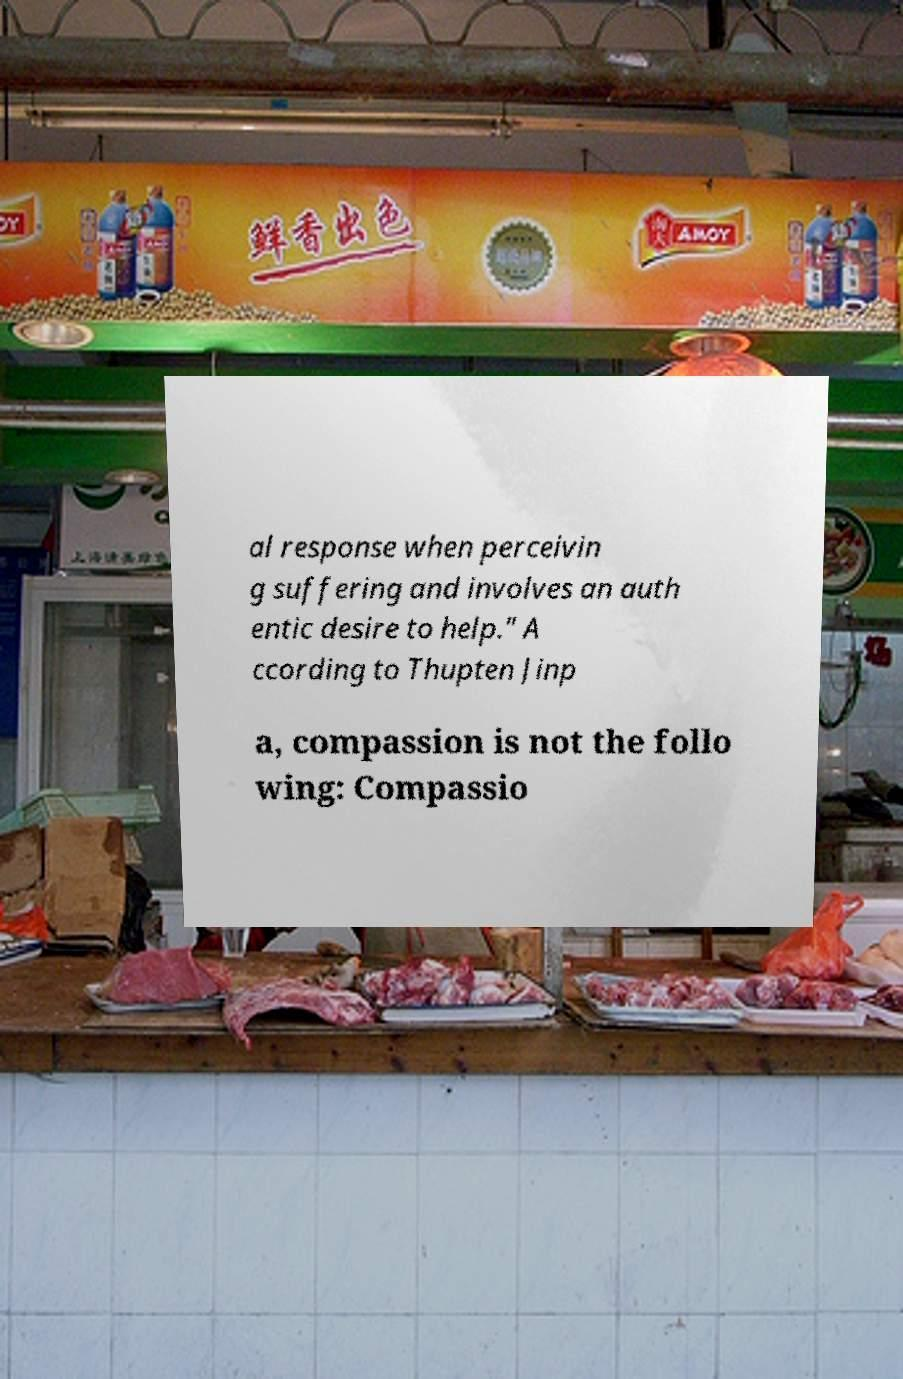For documentation purposes, I need the text within this image transcribed. Could you provide that? al response when perceivin g suffering and involves an auth entic desire to help." A ccording to Thupten Jinp a, compassion is not the follo wing: Compassio 